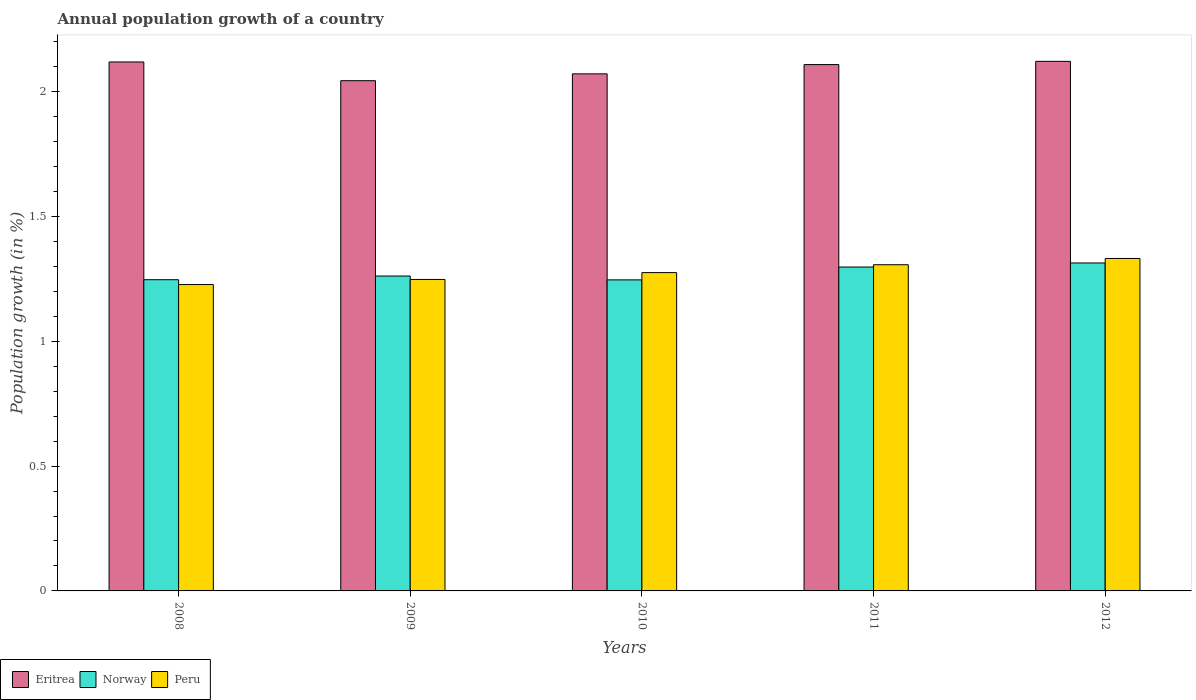Are the number of bars per tick equal to the number of legend labels?
Your answer should be compact. Yes. How many bars are there on the 1st tick from the right?
Your answer should be compact. 3. What is the label of the 3rd group of bars from the left?
Make the answer very short. 2010. What is the annual population growth in Norway in 2010?
Make the answer very short. 1.25. Across all years, what is the maximum annual population growth in Peru?
Offer a terse response. 1.33. Across all years, what is the minimum annual population growth in Norway?
Make the answer very short. 1.25. What is the total annual population growth in Norway in the graph?
Provide a short and direct response. 6.36. What is the difference between the annual population growth in Norway in 2009 and that in 2011?
Make the answer very short. -0.04. What is the difference between the annual population growth in Peru in 2011 and the annual population growth in Eritrea in 2012?
Offer a terse response. -0.81. What is the average annual population growth in Peru per year?
Your answer should be very brief. 1.28. In the year 2008, what is the difference between the annual population growth in Peru and annual population growth in Eritrea?
Keep it short and to the point. -0.89. What is the ratio of the annual population growth in Peru in 2009 to that in 2011?
Provide a short and direct response. 0.95. Is the annual population growth in Norway in 2010 less than that in 2012?
Provide a succinct answer. Yes. Is the difference between the annual population growth in Peru in 2008 and 2011 greater than the difference between the annual population growth in Eritrea in 2008 and 2011?
Give a very brief answer. No. What is the difference between the highest and the second highest annual population growth in Norway?
Keep it short and to the point. 0.02. What is the difference between the highest and the lowest annual population growth in Peru?
Ensure brevity in your answer.  0.1. What does the 3rd bar from the left in 2011 represents?
Your answer should be compact. Peru. How many bars are there?
Keep it short and to the point. 15. Are all the bars in the graph horizontal?
Ensure brevity in your answer.  No. How many legend labels are there?
Make the answer very short. 3. What is the title of the graph?
Ensure brevity in your answer.  Annual population growth of a country. What is the label or title of the Y-axis?
Offer a terse response. Population growth (in %). What is the Population growth (in %) in Eritrea in 2008?
Give a very brief answer. 2.12. What is the Population growth (in %) of Norway in 2008?
Your answer should be compact. 1.25. What is the Population growth (in %) in Peru in 2008?
Keep it short and to the point. 1.23. What is the Population growth (in %) in Eritrea in 2009?
Your response must be concise. 2.04. What is the Population growth (in %) in Norway in 2009?
Ensure brevity in your answer.  1.26. What is the Population growth (in %) of Peru in 2009?
Make the answer very short. 1.25. What is the Population growth (in %) of Eritrea in 2010?
Your answer should be compact. 2.07. What is the Population growth (in %) of Norway in 2010?
Offer a terse response. 1.25. What is the Population growth (in %) of Peru in 2010?
Ensure brevity in your answer.  1.27. What is the Population growth (in %) of Eritrea in 2011?
Your response must be concise. 2.11. What is the Population growth (in %) in Norway in 2011?
Provide a succinct answer. 1.3. What is the Population growth (in %) in Peru in 2011?
Offer a very short reply. 1.31. What is the Population growth (in %) in Eritrea in 2012?
Give a very brief answer. 2.12. What is the Population growth (in %) in Norway in 2012?
Your response must be concise. 1.31. What is the Population growth (in %) of Peru in 2012?
Keep it short and to the point. 1.33. Across all years, what is the maximum Population growth (in %) of Eritrea?
Provide a short and direct response. 2.12. Across all years, what is the maximum Population growth (in %) in Norway?
Offer a very short reply. 1.31. Across all years, what is the maximum Population growth (in %) in Peru?
Your response must be concise. 1.33. Across all years, what is the minimum Population growth (in %) of Eritrea?
Your answer should be very brief. 2.04. Across all years, what is the minimum Population growth (in %) in Norway?
Offer a terse response. 1.25. Across all years, what is the minimum Population growth (in %) of Peru?
Your response must be concise. 1.23. What is the total Population growth (in %) of Eritrea in the graph?
Your answer should be compact. 10.46. What is the total Population growth (in %) in Norway in the graph?
Ensure brevity in your answer.  6.36. What is the total Population growth (in %) in Peru in the graph?
Offer a terse response. 6.39. What is the difference between the Population growth (in %) in Eritrea in 2008 and that in 2009?
Offer a very short reply. 0.07. What is the difference between the Population growth (in %) of Norway in 2008 and that in 2009?
Give a very brief answer. -0.01. What is the difference between the Population growth (in %) in Peru in 2008 and that in 2009?
Offer a very short reply. -0.02. What is the difference between the Population growth (in %) of Eritrea in 2008 and that in 2010?
Your response must be concise. 0.05. What is the difference between the Population growth (in %) in Norway in 2008 and that in 2010?
Your answer should be compact. 0. What is the difference between the Population growth (in %) of Peru in 2008 and that in 2010?
Your answer should be very brief. -0.05. What is the difference between the Population growth (in %) in Eritrea in 2008 and that in 2011?
Your answer should be compact. 0.01. What is the difference between the Population growth (in %) in Norway in 2008 and that in 2011?
Your answer should be compact. -0.05. What is the difference between the Population growth (in %) in Peru in 2008 and that in 2011?
Make the answer very short. -0.08. What is the difference between the Population growth (in %) in Eritrea in 2008 and that in 2012?
Provide a succinct answer. -0. What is the difference between the Population growth (in %) of Norway in 2008 and that in 2012?
Provide a short and direct response. -0.07. What is the difference between the Population growth (in %) of Peru in 2008 and that in 2012?
Keep it short and to the point. -0.1. What is the difference between the Population growth (in %) of Eritrea in 2009 and that in 2010?
Offer a terse response. -0.03. What is the difference between the Population growth (in %) in Norway in 2009 and that in 2010?
Your answer should be very brief. 0.02. What is the difference between the Population growth (in %) of Peru in 2009 and that in 2010?
Your response must be concise. -0.03. What is the difference between the Population growth (in %) of Eritrea in 2009 and that in 2011?
Your response must be concise. -0.06. What is the difference between the Population growth (in %) of Norway in 2009 and that in 2011?
Make the answer very short. -0.04. What is the difference between the Population growth (in %) of Peru in 2009 and that in 2011?
Keep it short and to the point. -0.06. What is the difference between the Population growth (in %) of Eritrea in 2009 and that in 2012?
Give a very brief answer. -0.08. What is the difference between the Population growth (in %) in Norway in 2009 and that in 2012?
Keep it short and to the point. -0.05. What is the difference between the Population growth (in %) of Peru in 2009 and that in 2012?
Your answer should be very brief. -0.08. What is the difference between the Population growth (in %) of Eritrea in 2010 and that in 2011?
Offer a terse response. -0.04. What is the difference between the Population growth (in %) of Norway in 2010 and that in 2011?
Your answer should be compact. -0.05. What is the difference between the Population growth (in %) in Peru in 2010 and that in 2011?
Offer a very short reply. -0.03. What is the difference between the Population growth (in %) in Eritrea in 2010 and that in 2012?
Your answer should be compact. -0.05. What is the difference between the Population growth (in %) of Norway in 2010 and that in 2012?
Provide a short and direct response. -0.07. What is the difference between the Population growth (in %) in Peru in 2010 and that in 2012?
Offer a very short reply. -0.06. What is the difference between the Population growth (in %) in Eritrea in 2011 and that in 2012?
Ensure brevity in your answer.  -0.01. What is the difference between the Population growth (in %) of Norway in 2011 and that in 2012?
Ensure brevity in your answer.  -0.02. What is the difference between the Population growth (in %) in Peru in 2011 and that in 2012?
Give a very brief answer. -0.03. What is the difference between the Population growth (in %) of Eritrea in 2008 and the Population growth (in %) of Norway in 2009?
Make the answer very short. 0.86. What is the difference between the Population growth (in %) in Eritrea in 2008 and the Population growth (in %) in Peru in 2009?
Give a very brief answer. 0.87. What is the difference between the Population growth (in %) in Norway in 2008 and the Population growth (in %) in Peru in 2009?
Your response must be concise. -0. What is the difference between the Population growth (in %) in Eritrea in 2008 and the Population growth (in %) in Norway in 2010?
Provide a succinct answer. 0.87. What is the difference between the Population growth (in %) in Eritrea in 2008 and the Population growth (in %) in Peru in 2010?
Offer a terse response. 0.84. What is the difference between the Population growth (in %) of Norway in 2008 and the Population growth (in %) of Peru in 2010?
Your response must be concise. -0.03. What is the difference between the Population growth (in %) of Eritrea in 2008 and the Population growth (in %) of Norway in 2011?
Offer a very short reply. 0.82. What is the difference between the Population growth (in %) of Eritrea in 2008 and the Population growth (in %) of Peru in 2011?
Keep it short and to the point. 0.81. What is the difference between the Population growth (in %) of Norway in 2008 and the Population growth (in %) of Peru in 2011?
Provide a succinct answer. -0.06. What is the difference between the Population growth (in %) in Eritrea in 2008 and the Population growth (in %) in Norway in 2012?
Give a very brief answer. 0.81. What is the difference between the Population growth (in %) in Eritrea in 2008 and the Population growth (in %) in Peru in 2012?
Provide a short and direct response. 0.79. What is the difference between the Population growth (in %) in Norway in 2008 and the Population growth (in %) in Peru in 2012?
Offer a terse response. -0.09. What is the difference between the Population growth (in %) in Eritrea in 2009 and the Population growth (in %) in Norway in 2010?
Ensure brevity in your answer.  0.8. What is the difference between the Population growth (in %) of Eritrea in 2009 and the Population growth (in %) of Peru in 2010?
Your answer should be compact. 0.77. What is the difference between the Population growth (in %) in Norway in 2009 and the Population growth (in %) in Peru in 2010?
Ensure brevity in your answer.  -0.01. What is the difference between the Population growth (in %) in Eritrea in 2009 and the Population growth (in %) in Norway in 2011?
Ensure brevity in your answer.  0.75. What is the difference between the Population growth (in %) of Eritrea in 2009 and the Population growth (in %) of Peru in 2011?
Your answer should be compact. 0.74. What is the difference between the Population growth (in %) of Norway in 2009 and the Population growth (in %) of Peru in 2011?
Ensure brevity in your answer.  -0.05. What is the difference between the Population growth (in %) in Eritrea in 2009 and the Population growth (in %) in Norway in 2012?
Offer a very short reply. 0.73. What is the difference between the Population growth (in %) of Eritrea in 2009 and the Population growth (in %) of Peru in 2012?
Make the answer very short. 0.71. What is the difference between the Population growth (in %) in Norway in 2009 and the Population growth (in %) in Peru in 2012?
Keep it short and to the point. -0.07. What is the difference between the Population growth (in %) of Eritrea in 2010 and the Population growth (in %) of Norway in 2011?
Offer a very short reply. 0.77. What is the difference between the Population growth (in %) in Eritrea in 2010 and the Population growth (in %) in Peru in 2011?
Offer a very short reply. 0.76. What is the difference between the Population growth (in %) of Norway in 2010 and the Population growth (in %) of Peru in 2011?
Make the answer very short. -0.06. What is the difference between the Population growth (in %) in Eritrea in 2010 and the Population growth (in %) in Norway in 2012?
Provide a short and direct response. 0.76. What is the difference between the Population growth (in %) in Eritrea in 2010 and the Population growth (in %) in Peru in 2012?
Provide a succinct answer. 0.74. What is the difference between the Population growth (in %) in Norway in 2010 and the Population growth (in %) in Peru in 2012?
Make the answer very short. -0.09. What is the difference between the Population growth (in %) in Eritrea in 2011 and the Population growth (in %) in Norway in 2012?
Provide a short and direct response. 0.79. What is the difference between the Population growth (in %) of Eritrea in 2011 and the Population growth (in %) of Peru in 2012?
Keep it short and to the point. 0.78. What is the difference between the Population growth (in %) of Norway in 2011 and the Population growth (in %) of Peru in 2012?
Your response must be concise. -0.03. What is the average Population growth (in %) of Eritrea per year?
Your response must be concise. 2.09. What is the average Population growth (in %) of Norway per year?
Provide a short and direct response. 1.27. What is the average Population growth (in %) of Peru per year?
Ensure brevity in your answer.  1.28. In the year 2008, what is the difference between the Population growth (in %) in Eritrea and Population growth (in %) in Norway?
Your answer should be very brief. 0.87. In the year 2008, what is the difference between the Population growth (in %) in Eritrea and Population growth (in %) in Peru?
Your response must be concise. 0.89. In the year 2008, what is the difference between the Population growth (in %) of Norway and Population growth (in %) of Peru?
Provide a succinct answer. 0.02. In the year 2009, what is the difference between the Population growth (in %) in Eritrea and Population growth (in %) in Norway?
Your answer should be compact. 0.78. In the year 2009, what is the difference between the Population growth (in %) in Eritrea and Population growth (in %) in Peru?
Give a very brief answer. 0.8. In the year 2009, what is the difference between the Population growth (in %) in Norway and Population growth (in %) in Peru?
Your answer should be compact. 0.01. In the year 2010, what is the difference between the Population growth (in %) in Eritrea and Population growth (in %) in Norway?
Make the answer very short. 0.83. In the year 2010, what is the difference between the Population growth (in %) of Eritrea and Population growth (in %) of Peru?
Provide a short and direct response. 0.8. In the year 2010, what is the difference between the Population growth (in %) in Norway and Population growth (in %) in Peru?
Give a very brief answer. -0.03. In the year 2011, what is the difference between the Population growth (in %) in Eritrea and Population growth (in %) in Norway?
Your answer should be compact. 0.81. In the year 2011, what is the difference between the Population growth (in %) in Eritrea and Population growth (in %) in Peru?
Provide a short and direct response. 0.8. In the year 2011, what is the difference between the Population growth (in %) in Norway and Population growth (in %) in Peru?
Ensure brevity in your answer.  -0.01. In the year 2012, what is the difference between the Population growth (in %) of Eritrea and Population growth (in %) of Norway?
Give a very brief answer. 0.81. In the year 2012, what is the difference between the Population growth (in %) in Eritrea and Population growth (in %) in Peru?
Provide a short and direct response. 0.79. In the year 2012, what is the difference between the Population growth (in %) in Norway and Population growth (in %) in Peru?
Provide a succinct answer. -0.02. What is the ratio of the Population growth (in %) of Eritrea in 2008 to that in 2009?
Ensure brevity in your answer.  1.04. What is the ratio of the Population growth (in %) of Norway in 2008 to that in 2009?
Your response must be concise. 0.99. What is the ratio of the Population growth (in %) of Peru in 2008 to that in 2009?
Offer a very short reply. 0.98. What is the ratio of the Population growth (in %) in Peru in 2008 to that in 2010?
Your answer should be very brief. 0.96. What is the ratio of the Population growth (in %) in Norway in 2008 to that in 2011?
Provide a succinct answer. 0.96. What is the ratio of the Population growth (in %) in Peru in 2008 to that in 2011?
Your answer should be very brief. 0.94. What is the ratio of the Population growth (in %) in Eritrea in 2008 to that in 2012?
Your response must be concise. 1. What is the ratio of the Population growth (in %) in Norway in 2008 to that in 2012?
Your response must be concise. 0.95. What is the ratio of the Population growth (in %) of Peru in 2008 to that in 2012?
Offer a very short reply. 0.92. What is the ratio of the Population growth (in %) of Eritrea in 2009 to that in 2010?
Provide a short and direct response. 0.99. What is the ratio of the Population growth (in %) of Norway in 2009 to that in 2010?
Give a very brief answer. 1.01. What is the ratio of the Population growth (in %) in Peru in 2009 to that in 2010?
Make the answer very short. 0.98. What is the ratio of the Population growth (in %) in Eritrea in 2009 to that in 2011?
Provide a succinct answer. 0.97. What is the ratio of the Population growth (in %) in Norway in 2009 to that in 2011?
Ensure brevity in your answer.  0.97. What is the ratio of the Population growth (in %) of Peru in 2009 to that in 2011?
Ensure brevity in your answer.  0.95. What is the ratio of the Population growth (in %) of Eritrea in 2009 to that in 2012?
Provide a short and direct response. 0.96. What is the ratio of the Population growth (in %) in Norway in 2009 to that in 2012?
Give a very brief answer. 0.96. What is the ratio of the Population growth (in %) in Peru in 2009 to that in 2012?
Ensure brevity in your answer.  0.94. What is the ratio of the Population growth (in %) in Eritrea in 2010 to that in 2011?
Offer a terse response. 0.98. What is the ratio of the Population growth (in %) in Norway in 2010 to that in 2011?
Your answer should be very brief. 0.96. What is the ratio of the Population growth (in %) of Peru in 2010 to that in 2011?
Offer a very short reply. 0.98. What is the ratio of the Population growth (in %) of Eritrea in 2010 to that in 2012?
Provide a succinct answer. 0.98. What is the ratio of the Population growth (in %) in Norway in 2010 to that in 2012?
Keep it short and to the point. 0.95. What is the ratio of the Population growth (in %) of Peru in 2010 to that in 2012?
Your response must be concise. 0.96. What is the ratio of the Population growth (in %) of Norway in 2011 to that in 2012?
Keep it short and to the point. 0.99. What is the ratio of the Population growth (in %) in Peru in 2011 to that in 2012?
Your response must be concise. 0.98. What is the difference between the highest and the second highest Population growth (in %) of Eritrea?
Provide a short and direct response. 0. What is the difference between the highest and the second highest Population growth (in %) in Norway?
Ensure brevity in your answer.  0.02. What is the difference between the highest and the second highest Population growth (in %) in Peru?
Offer a very short reply. 0.03. What is the difference between the highest and the lowest Population growth (in %) of Eritrea?
Provide a short and direct response. 0.08. What is the difference between the highest and the lowest Population growth (in %) in Norway?
Provide a short and direct response. 0.07. What is the difference between the highest and the lowest Population growth (in %) in Peru?
Make the answer very short. 0.1. 